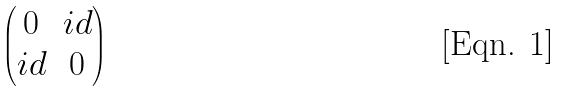Convert formula to latex. <formula><loc_0><loc_0><loc_500><loc_500>\begin{pmatrix} 0 & i d \\ i d & 0 \end{pmatrix}</formula> 